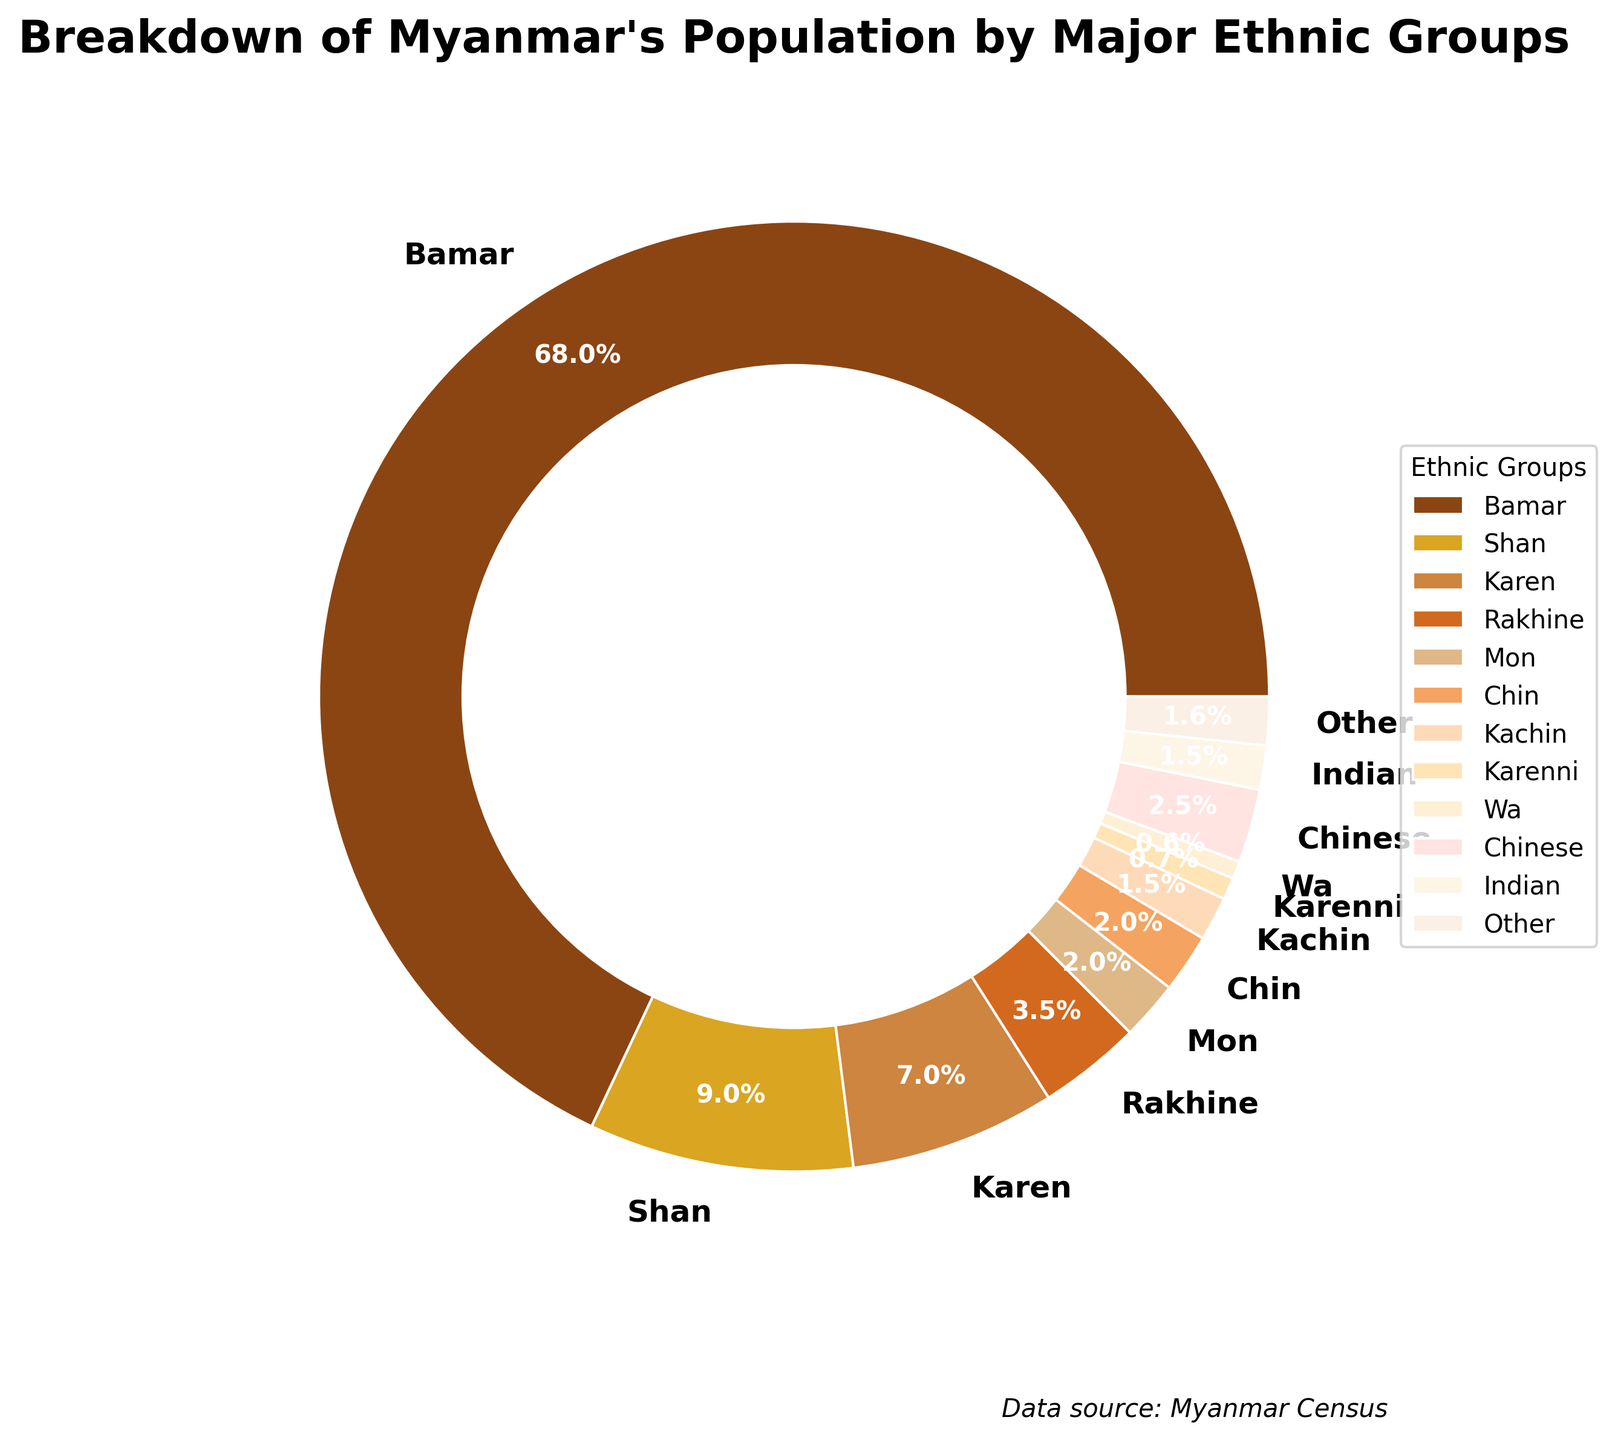What's the largest ethnic group in Myanmar according to the pie chart? According to the pie chart, the largest ethnic group is the one with the largest percentage. The Bamar group has the largest percentage at 68%.
Answer: Bamar Which ethnic group has a percentage closest to the Mon ethnic group? By looking at the pie chart, the Mon ethnic group has a percentage of 2%. The closest percentages to Mon are Chin (2%) and others (1.65%), but Chin is the closest match.
Answer: Chin How much larger is the Bamar population compared to the combined percentages of the Rakhine, Mon, and Chin groups? The Bamar population is 68%. The combined percentage of Rakhine (3.5%), Mon (2%), and Chin (2%) is 3.5 + 2 + 2 = 7.5%. 68% - 7.5% = 60.5%. So, the Bamar population is 60.5% larger.
Answer: 60.5% Which ethnic group percentage is represented by a light brown color in the pie chart? The light brown color represents the Indian ethnic group, with a percentage of 1.5%. This can be determined by matching the colors with their corresponding segments in the pie chart.
Answer: Indian Is the combined percentage of the Shan and Karen groups more or less than 20%? The Shan group is 9% and the Karen group is 7% in the pie chart. Combined, they are 9 + 7 = 16%, which is less than 20%.
Answer: Less How does the Indian population percentage compare to the Chinese population percentage? The pie chart shows the Indian population at 1.5% and the Chinese population at 2.5%. Therefore, the Indian population percentage is 2.5% - 1.5% = 1% less than the Chinese population percentage.
Answer: 1% less What fraction of the total population is represented by the "Other" ethnic group, and how would this be expressed as a percentage? The "Other" ethnic group represents 1.65% of the total population, according to the pie chart. In fraction form, this is 1.65/100 or approximately 1/61.
Answer: 1.65% Which groups together make up more than 80% of Myanmar's population? The Bamar group is 68%, and adding the Shan (9%) and Karen (7%) groups: 68 + 9 + 7 = 84%, which is more than 80%. Therefore, Bamar, Shan, and Karen together make up more than 80%.
Answer: Bamar, Shan, and Karen Identify the three smallest ethnic groups by percentage and their combined total. The three smallest ethnic groups by percentage from the pie chart are Karenni (0.75%), Wa (0.6%), and Other (1.65%). Their combined total is 0.75 + 0.6 + 1.65 = 3%.
Answer: 3% What percentage of the population is represented by non-Burmese (non-Bamar) ethnic groups? The Bamar group represents 68%, so the non-Burmese population is 100% - 68% = 32%.
Answer: 32% 